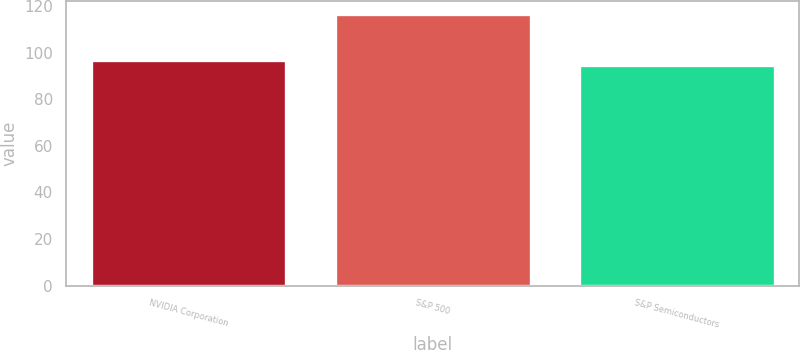Convert chart to OTSL. <chart><loc_0><loc_0><loc_500><loc_500><bar_chart><fcel>NVIDIA Corporation<fcel>S&P 500<fcel>S&P Semiconductors<nl><fcel>96.98<fcel>116.39<fcel>94.82<nl></chart> 